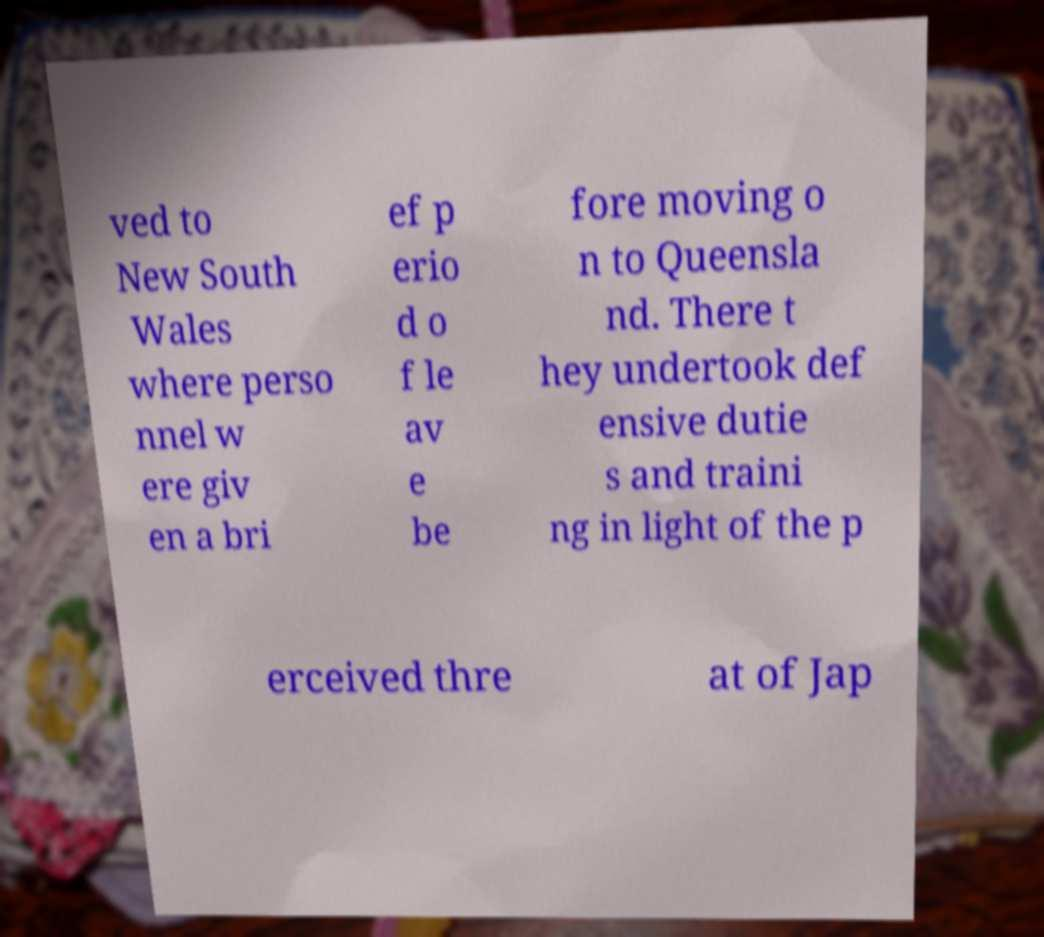Can you accurately transcribe the text from the provided image for me? ved to New South Wales where perso nnel w ere giv en a bri ef p erio d o f le av e be fore moving o n to Queensla nd. There t hey undertook def ensive dutie s and traini ng in light of the p erceived thre at of Jap 